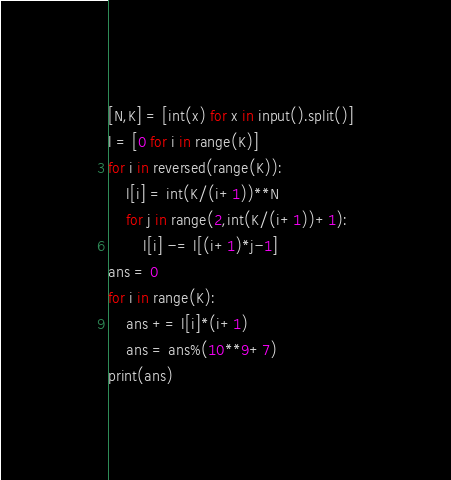Convert code to text. <code><loc_0><loc_0><loc_500><loc_500><_Python_>[N,K] = [int(x) for x in input().split()]
l = [0 for i in range(K)]
for i in reversed(range(K)):
    l[i] = int(K/(i+1))**N
    for j in range(2,int(K/(i+1))+1):
        l[i] -= l[(i+1)*j-1]
ans = 0
for i in range(K):
    ans += l[i]*(i+1)
    ans = ans%(10**9+7)
print(ans)</code> 